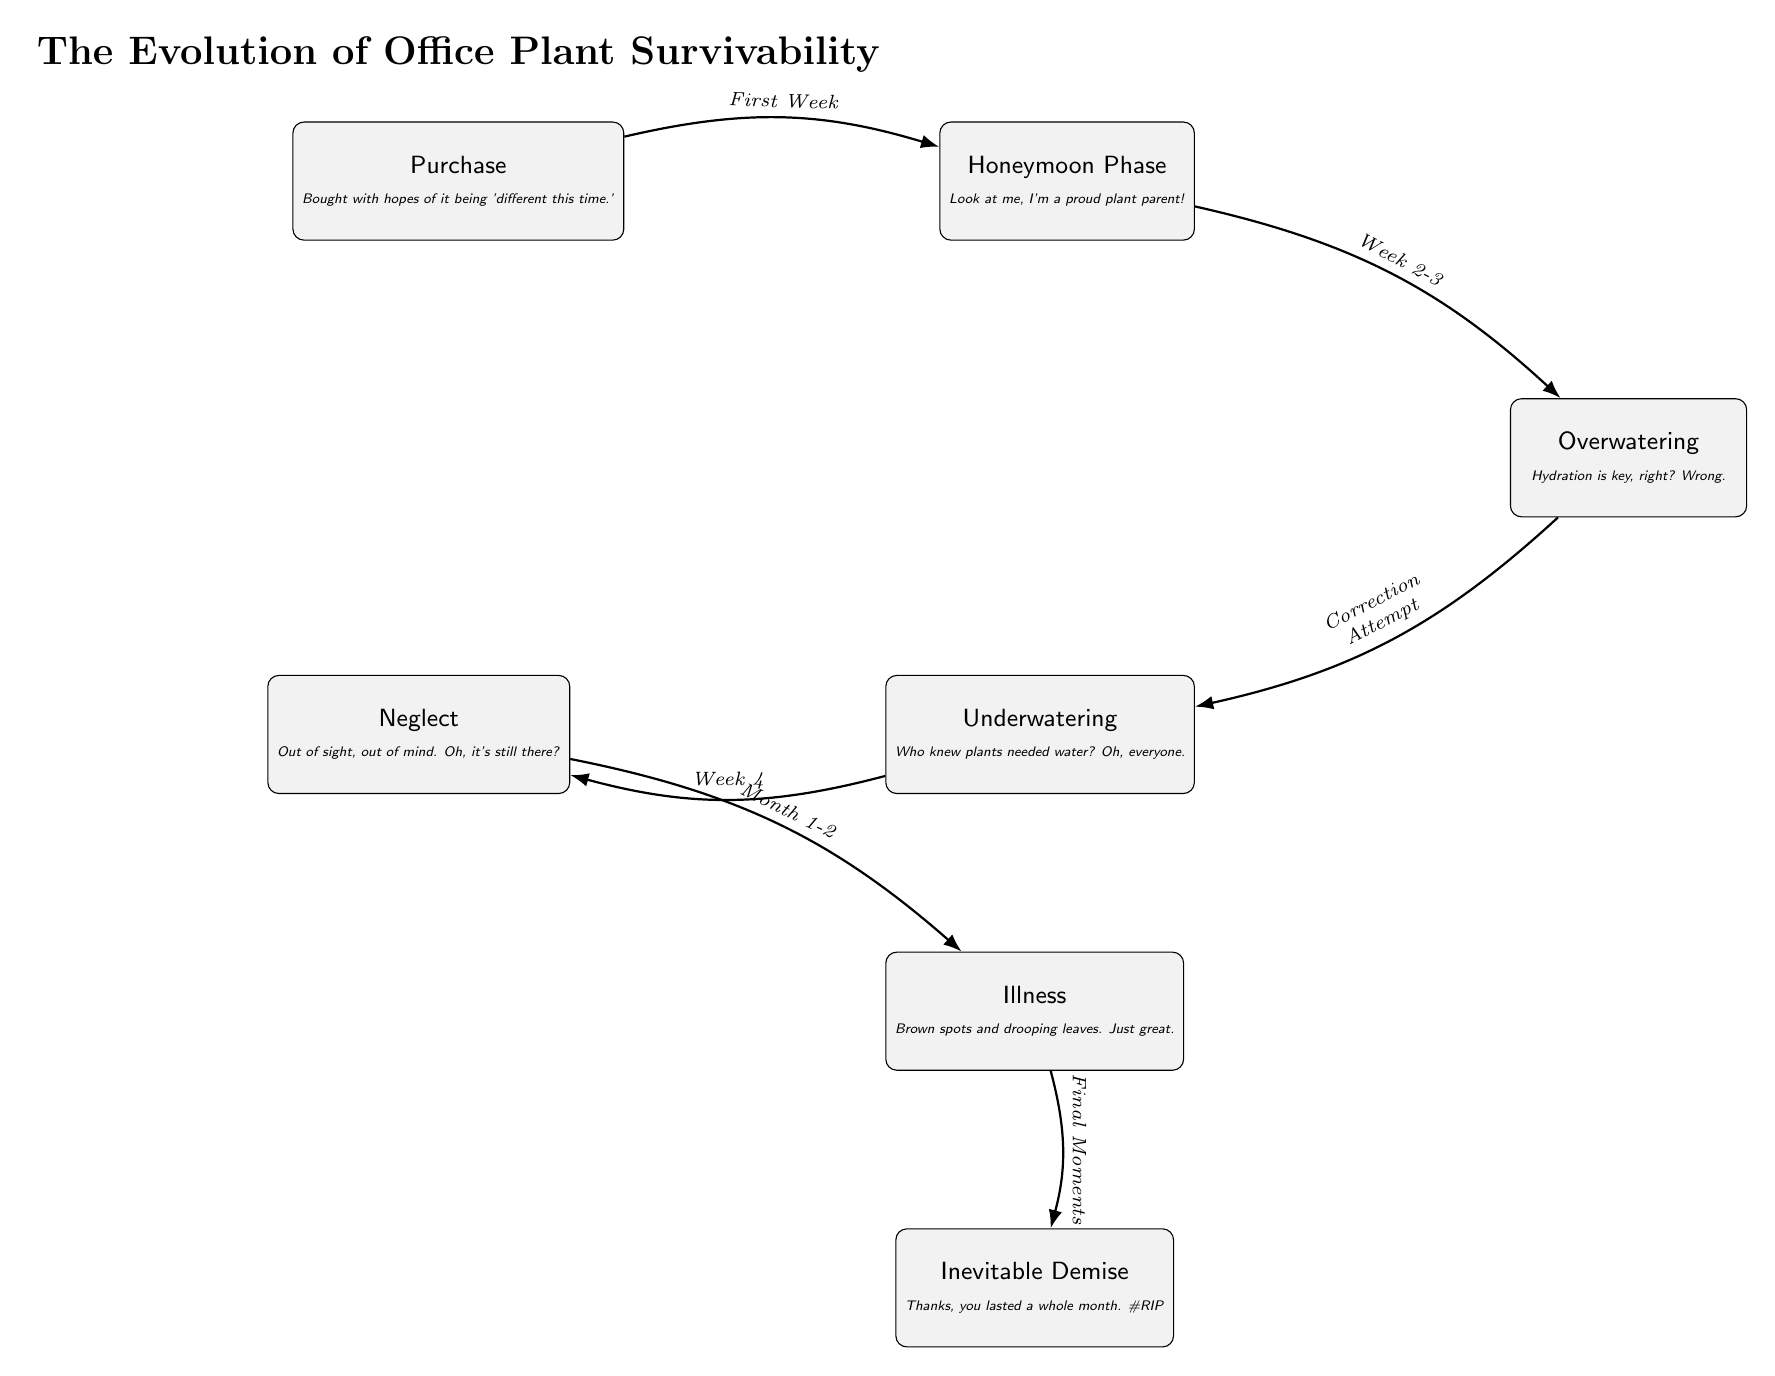What is the first stage in the diagram? The diagram starts with the 'Purchase' stage, which represents the initial action of acquiring the plant.
Answer: Purchase How many total stages are represented in the diagram? There are a total of six stages shown, from 'Purchase' to 'Inevitable Demise.'
Answer: Six What stage follows the 'Honeymoon Phase'? The second stage is 'Overwatering,' which follows the initial excitement of the 'Honeymoon Phase.'
Answer: Overwatering What humorous commentary is associated with 'Illness'? The commentary for 'Illness' is, "Brown spots and drooping leaves. Just great." This highlights the unsightly symptoms the plant exhibits as it struggles.
Answer: Brown spots and drooping leaves. Just great Which stage leads to 'Neglect'? The 'Underwatering' stage leads to 'Neglect,' indicating that the plant is not receiving adequate care or attention.
Answer: Underwatering How does the diagram suggest transitioning from 'Overwatering' to 'Underwatering'? The transition from 'Overwatering' to 'Underwatering' is marked by the label 'Correction Attempt,' implying an attempt to remedy excessive watering that results in neglect.
Answer: Correction Attempt What does the 'Inevitable Demise' stage comment on the plant's lifespan? The commentary for 'Inevitable Demise' is, "Thanks, you lasted a whole month. #RIP," suggesting a short and unsatisfactory lifespan of the plant.
Answer: Thanks, you lasted a whole month. #RIP Which stage is indicated to occur between 'Neglect' and 'Inevitable Demise'? The stage that occurs in between is 'Illness,' where the plant shows distress before it ultimately dies.
Answer: Illness How does the diagram indicate an emotional evolution of a plant parent? The progression from 'Purchase' to 'Honeymoon Phase' to the eventual stages of neglect and demise reflects the emotional journey of plant ownership, highlighting both hope and eventual despair.
Answer: Emotional journey What is the relationship between 'Purchase' and 'Honeymoon Phase'? 'Honeymoon Phase' directly follows 'Purchase,' indicating a positive initial sentiment right after acquiring the plant.
Answer: Directly follows 